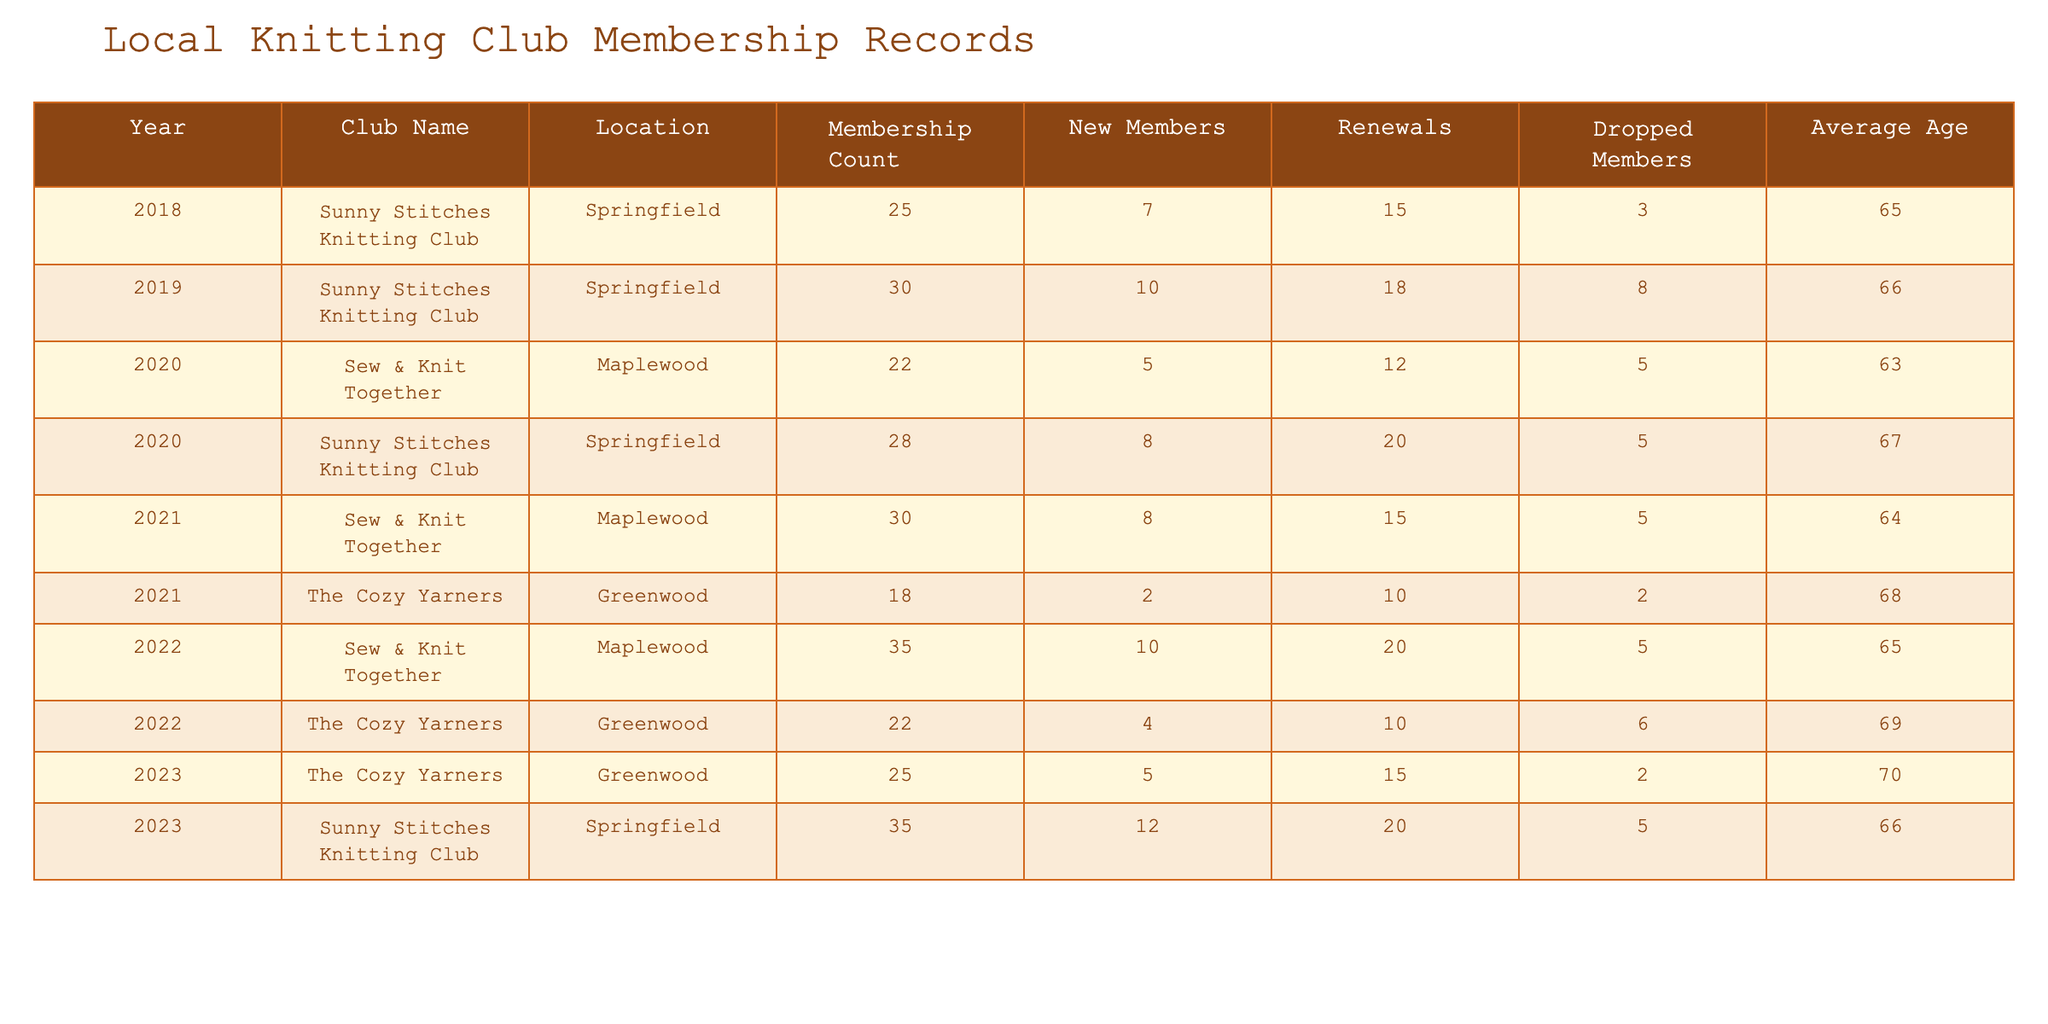What was the membership count for Sunny Stitches Knitting Club in 2023? The table shows that in 2023, the membership count for Sunny Stitches Knitting Club is listed as 35.
Answer: 35 How many new members joined The Cozy Yarners in 2022? According to the table, The Cozy Yarners had 4 new members in 2022.
Answer: 4 What is the total membership count for Sew & Knit Together from 2020 to 2022? The membership counts for Sew & Knit Together in that period are 22 (2020), 30 (2021), and 35 (2022). Adding these gives 22 + 30 + 35 = 87.
Answer: 87 Was there a decrease in membership for any club in 2021 compared to 2020? The table shows Sew & Knit Together had an increase from 22 to 30, while The Cozy Yarners appeared for the first time in 2021. Therefore, among existing clubs, there was no decrease.
Answer: No What is the average age of members in the Sunny Stitches Knitting Club over the years provided? The ages are 65 (2018), 66 (2019), 67 (2020), 66 (2023). Calculating the average: (65 + 66 + 67 + 66) / 4 = 66.
Answer: 66 Which club had the highest average age of members in 2023, and what was it? The Cozy Yarners had an average age of 70 in 2023, while Sunny Stitches had 66. Therefore, The Cozy Yarners had the highest average age.
Answer: 70 How many members dropped from Sunny Stitches Knitting Club in 2020? The table indicates that Sunny Stitches Knitting Club had 5 members drop in 2020.
Answer: 5 What is the total number of new members across all clubs in 2022? The new members for Sew & Knit Together were 10 and for The Cozy Yarners were 4. Adding them gives: 10 + 4 = 14.
Answer: 14 Did the total membership of The Cozy Yarners increase from 2021 to 2023? The table shows that The Cozy Yarners had 18 members in 2021 and 25 in 2023, indicating an increase.
Answer: Yes What club had the lowest membership count in 2020? In 2020, Sew & Knit Together had a membership count of 22, which is lower than Sunny Stitches with 28 members.
Answer: Sew & Knit Together 